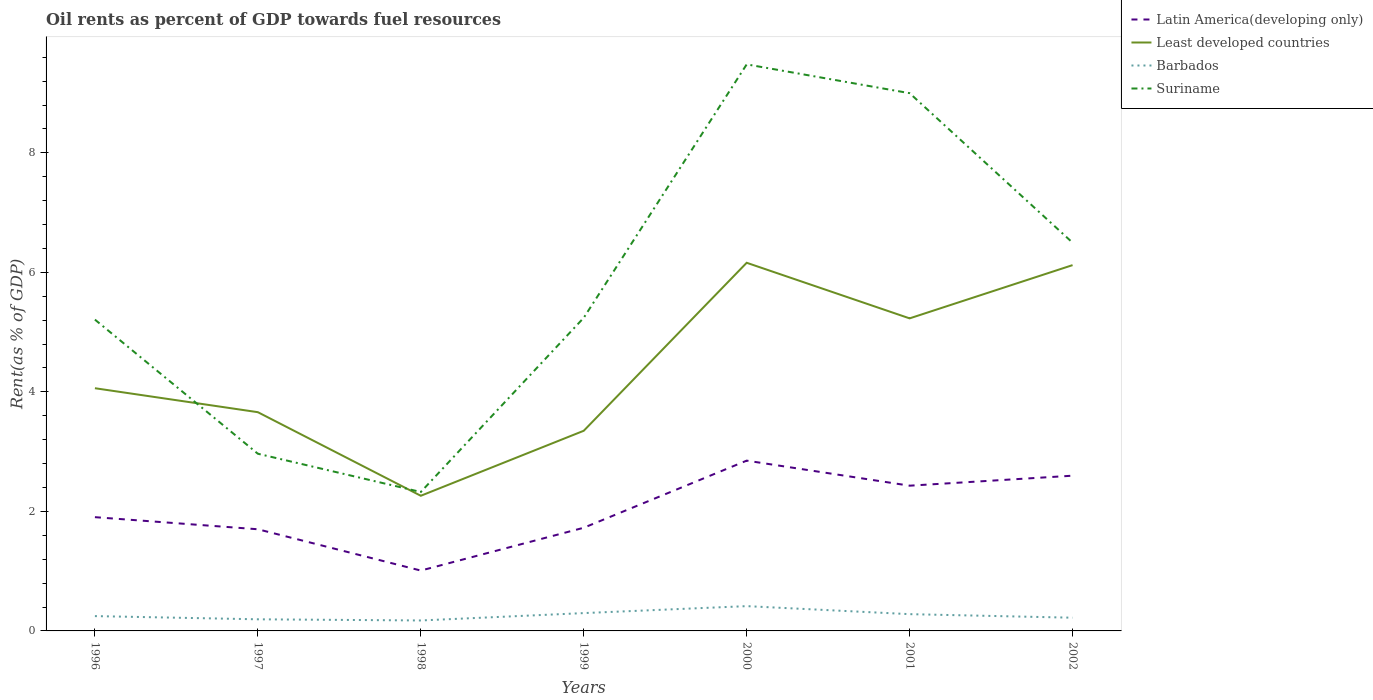Does the line corresponding to Latin America(developing only) intersect with the line corresponding to Least developed countries?
Offer a very short reply. No. Across all years, what is the maximum oil rent in Suriname?
Make the answer very short. 2.32. What is the total oil rent in Least developed countries in the graph?
Make the answer very short. -0.89. What is the difference between the highest and the second highest oil rent in Latin America(developing only)?
Offer a very short reply. 1.84. What is the difference between the highest and the lowest oil rent in Barbados?
Ensure brevity in your answer.  3. Is the oil rent in Least developed countries strictly greater than the oil rent in Latin America(developing only) over the years?
Give a very brief answer. No. How many years are there in the graph?
Offer a very short reply. 7. Does the graph contain any zero values?
Offer a terse response. No. Does the graph contain grids?
Give a very brief answer. No. How are the legend labels stacked?
Your response must be concise. Vertical. What is the title of the graph?
Your answer should be compact. Oil rents as percent of GDP towards fuel resources. Does "Bhutan" appear as one of the legend labels in the graph?
Offer a very short reply. No. What is the label or title of the X-axis?
Your answer should be compact. Years. What is the label or title of the Y-axis?
Offer a terse response. Rent(as % of GDP). What is the Rent(as % of GDP) in Latin America(developing only) in 1996?
Give a very brief answer. 1.9. What is the Rent(as % of GDP) of Least developed countries in 1996?
Ensure brevity in your answer.  4.06. What is the Rent(as % of GDP) of Barbados in 1996?
Ensure brevity in your answer.  0.25. What is the Rent(as % of GDP) in Suriname in 1996?
Make the answer very short. 5.21. What is the Rent(as % of GDP) of Latin America(developing only) in 1997?
Keep it short and to the point. 1.7. What is the Rent(as % of GDP) in Least developed countries in 1997?
Provide a short and direct response. 3.66. What is the Rent(as % of GDP) of Barbados in 1997?
Your answer should be very brief. 0.19. What is the Rent(as % of GDP) in Suriname in 1997?
Ensure brevity in your answer.  2.97. What is the Rent(as % of GDP) of Latin America(developing only) in 1998?
Your answer should be very brief. 1.01. What is the Rent(as % of GDP) in Least developed countries in 1998?
Keep it short and to the point. 2.26. What is the Rent(as % of GDP) of Barbados in 1998?
Make the answer very short. 0.18. What is the Rent(as % of GDP) in Suriname in 1998?
Keep it short and to the point. 2.32. What is the Rent(as % of GDP) in Latin America(developing only) in 1999?
Offer a very short reply. 1.73. What is the Rent(as % of GDP) in Least developed countries in 1999?
Give a very brief answer. 3.35. What is the Rent(as % of GDP) of Barbados in 1999?
Give a very brief answer. 0.3. What is the Rent(as % of GDP) in Suriname in 1999?
Your answer should be very brief. 5.24. What is the Rent(as % of GDP) of Latin America(developing only) in 2000?
Keep it short and to the point. 2.85. What is the Rent(as % of GDP) in Least developed countries in 2000?
Your answer should be very brief. 6.16. What is the Rent(as % of GDP) in Barbados in 2000?
Your response must be concise. 0.41. What is the Rent(as % of GDP) in Suriname in 2000?
Offer a terse response. 9.48. What is the Rent(as % of GDP) of Latin America(developing only) in 2001?
Keep it short and to the point. 2.43. What is the Rent(as % of GDP) of Least developed countries in 2001?
Your answer should be compact. 5.23. What is the Rent(as % of GDP) in Barbados in 2001?
Provide a short and direct response. 0.28. What is the Rent(as % of GDP) in Suriname in 2001?
Your answer should be compact. 9. What is the Rent(as % of GDP) in Latin America(developing only) in 2002?
Make the answer very short. 2.6. What is the Rent(as % of GDP) in Least developed countries in 2002?
Make the answer very short. 6.12. What is the Rent(as % of GDP) in Barbados in 2002?
Your answer should be compact. 0.22. What is the Rent(as % of GDP) in Suriname in 2002?
Offer a terse response. 6.5. Across all years, what is the maximum Rent(as % of GDP) in Latin America(developing only)?
Offer a very short reply. 2.85. Across all years, what is the maximum Rent(as % of GDP) in Least developed countries?
Your response must be concise. 6.16. Across all years, what is the maximum Rent(as % of GDP) in Barbados?
Your answer should be very brief. 0.41. Across all years, what is the maximum Rent(as % of GDP) of Suriname?
Your answer should be very brief. 9.48. Across all years, what is the minimum Rent(as % of GDP) in Latin America(developing only)?
Provide a succinct answer. 1.01. Across all years, what is the minimum Rent(as % of GDP) in Least developed countries?
Make the answer very short. 2.26. Across all years, what is the minimum Rent(as % of GDP) of Barbados?
Your answer should be compact. 0.18. Across all years, what is the minimum Rent(as % of GDP) in Suriname?
Your answer should be compact. 2.32. What is the total Rent(as % of GDP) of Latin America(developing only) in the graph?
Provide a short and direct response. 14.22. What is the total Rent(as % of GDP) in Least developed countries in the graph?
Offer a terse response. 30.85. What is the total Rent(as % of GDP) of Barbados in the graph?
Provide a succinct answer. 1.83. What is the total Rent(as % of GDP) in Suriname in the graph?
Ensure brevity in your answer.  40.72. What is the difference between the Rent(as % of GDP) of Latin America(developing only) in 1996 and that in 1997?
Offer a terse response. 0.2. What is the difference between the Rent(as % of GDP) of Least developed countries in 1996 and that in 1997?
Keep it short and to the point. 0.4. What is the difference between the Rent(as % of GDP) in Barbados in 1996 and that in 1997?
Provide a succinct answer. 0.05. What is the difference between the Rent(as % of GDP) in Suriname in 1996 and that in 1997?
Make the answer very short. 2.24. What is the difference between the Rent(as % of GDP) in Latin America(developing only) in 1996 and that in 1998?
Provide a short and direct response. 0.89. What is the difference between the Rent(as % of GDP) in Least developed countries in 1996 and that in 1998?
Ensure brevity in your answer.  1.8. What is the difference between the Rent(as % of GDP) in Barbados in 1996 and that in 1998?
Make the answer very short. 0.07. What is the difference between the Rent(as % of GDP) of Suriname in 1996 and that in 1998?
Give a very brief answer. 2.88. What is the difference between the Rent(as % of GDP) in Latin America(developing only) in 1996 and that in 1999?
Offer a very short reply. 0.18. What is the difference between the Rent(as % of GDP) in Least developed countries in 1996 and that in 1999?
Make the answer very short. 0.71. What is the difference between the Rent(as % of GDP) in Barbados in 1996 and that in 1999?
Your answer should be compact. -0.05. What is the difference between the Rent(as % of GDP) in Suriname in 1996 and that in 1999?
Keep it short and to the point. -0.03. What is the difference between the Rent(as % of GDP) of Latin America(developing only) in 1996 and that in 2000?
Provide a short and direct response. -0.95. What is the difference between the Rent(as % of GDP) of Least developed countries in 1996 and that in 2000?
Your response must be concise. -2.1. What is the difference between the Rent(as % of GDP) in Barbados in 1996 and that in 2000?
Your answer should be very brief. -0.17. What is the difference between the Rent(as % of GDP) in Suriname in 1996 and that in 2000?
Your answer should be compact. -4.27. What is the difference between the Rent(as % of GDP) of Latin America(developing only) in 1996 and that in 2001?
Offer a very short reply. -0.53. What is the difference between the Rent(as % of GDP) in Least developed countries in 1996 and that in 2001?
Make the answer very short. -1.17. What is the difference between the Rent(as % of GDP) in Barbados in 1996 and that in 2001?
Keep it short and to the point. -0.03. What is the difference between the Rent(as % of GDP) of Suriname in 1996 and that in 2001?
Ensure brevity in your answer.  -3.79. What is the difference between the Rent(as % of GDP) in Latin America(developing only) in 1996 and that in 2002?
Make the answer very short. -0.69. What is the difference between the Rent(as % of GDP) in Least developed countries in 1996 and that in 2002?
Your answer should be very brief. -2.06. What is the difference between the Rent(as % of GDP) of Barbados in 1996 and that in 2002?
Your answer should be very brief. 0.03. What is the difference between the Rent(as % of GDP) of Suriname in 1996 and that in 2002?
Your response must be concise. -1.29. What is the difference between the Rent(as % of GDP) of Latin America(developing only) in 1997 and that in 1998?
Ensure brevity in your answer.  0.69. What is the difference between the Rent(as % of GDP) in Least developed countries in 1997 and that in 1998?
Offer a terse response. 1.4. What is the difference between the Rent(as % of GDP) of Barbados in 1997 and that in 1998?
Your answer should be very brief. 0.02. What is the difference between the Rent(as % of GDP) of Suriname in 1997 and that in 1998?
Make the answer very short. 0.64. What is the difference between the Rent(as % of GDP) of Latin America(developing only) in 1997 and that in 1999?
Offer a very short reply. -0.03. What is the difference between the Rent(as % of GDP) of Least developed countries in 1997 and that in 1999?
Give a very brief answer. 0.31. What is the difference between the Rent(as % of GDP) of Barbados in 1997 and that in 1999?
Ensure brevity in your answer.  -0.1. What is the difference between the Rent(as % of GDP) in Suriname in 1997 and that in 1999?
Provide a short and direct response. -2.27. What is the difference between the Rent(as % of GDP) of Latin America(developing only) in 1997 and that in 2000?
Make the answer very short. -1.15. What is the difference between the Rent(as % of GDP) in Least developed countries in 1997 and that in 2000?
Your answer should be compact. -2.5. What is the difference between the Rent(as % of GDP) of Barbados in 1997 and that in 2000?
Ensure brevity in your answer.  -0.22. What is the difference between the Rent(as % of GDP) in Suriname in 1997 and that in 2000?
Provide a succinct answer. -6.52. What is the difference between the Rent(as % of GDP) in Latin America(developing only) in 1997 and that in 2001?
Offer a terse response. -0.73. What is the difference between the Rent(as % of GDP) in Least developed countries in 1997 and that in 2001?
Ensure brevity in your answer.  -1.57. What is the difference between the Rent(as % of GDP) in Barbados in 1997 and that in 2001?
Provide a short and direct response. -0.09. What is the difference between the Rent(as % of GDP) of Suriname in 1997 and that in 2001?
Your answer should be very brief. -6.03. What is the difference between the Rent(as % of GDP) in Latin America(developing only) in 1997 and that in 2002?
Your answer should be compact. -0.9. What is the difference between the Rent(as % of GDP) in Least developed countries in 1997 and that in 2002?
Provide a succinct answer. -2.46. What is the difference between the Rent(as % of GDP) of Barbados in 1997 and that in 2002?
Ensure brevity in your answer.  -0.03. What is the difference between the Rent(as % of GDP) of Suriname in 1997 and that in 2002?
Make the answer very short. -3.53. What is the difference between the Rent(as % of GDP) of Latin America(developing only) in 1998 and that in 1999?
Your response must be concise. -0.72. What is the difference between the Rent(as % of GDP) in Least developed countries in 1998 and that in 1999?
Offer a terse response. -1.09. What is the difference between the Rent(as % of GDP) in Barbados in 1998 and that in 1999?
Offer a terse response. -0.12. What is the difference between the Rent(as % of GDP) in Suriname in 1998 and that in 1999?
Give a very brief answer. -2.92. What is the difference between the Rent(as % of GDP) in Latin America(developing only) in 1998 and that in 2000?
Offer a terse response. -1.84. What is the difference between the Rent(as % of GDP) of Least developed countries in 1998 and that in 2000?
Provide a short and direct response. -3.9. What is the difference between the Rent(as % of GDP) in Barbados in 1998 and that in 2000?
Your response must be concise. -0.24. What is the difference between the Rent(as % of GDP) in Suriname in 1998 and that in 2000?
Make the answer very short. -7.16. What is the difference between the Rent(as % of GDP) of Latin America(developing only) in 1998 and that in 2001?
Offer a very short reply. -1.42. What is the difference between the Rent(as % of GDP) in Least developed countries in 1998 and that in 2001?
Your response must be concise. -2.97. What is the difference between the Rent(as % of GDP) in Barbados in 1998 and that in 2001?
Keep it short and to the point. -0.11. What is the difference between the Rent(as % of GDP) in Suriname in 1998 and that in 2001?
Offer a terse response. -6.67. What is the difference between the Rent(as % of GDP) in Latin America(developing only) in 1998 and that in 2002?
Give a very brief answer. -1.59. What is the difference between the Rent(as % of GDP) in Least developed countries in 1998 and that in 2002?
Your answer should be compact. -3.86. What is the difference between the Rent(as % of GDP) of Barbados in 1998 and that in 2002?
Give a very brief answer. -0.05. What is the difference between the Rent(as % of GDP) of Suriname in 1998 and that in 2002?
Your response must be concise. -4.17. What is the difference between the Rent(as % of GDP) of Latin America(developing only) in 1999 and that in 2000?
Ensure brevity in your answer.  -1.12. What is the difference between the Rent(as % of GDP) in Least developed countries in 1999 and that in 2000?
Offer a very short reply. -2.81. What is the difference between the Rent(as % of GDP) in Barbados in 1999 and that in 2000?
Your answer should be very brief. -0.12. What is the difference between the Rent(as % of GDP) in Suriname in 1999 and that in 2000?
Make the answer very short. -4.24. What is the difference between the Rent(as % of GDP) of Latin America(developing only) in 1999 and that in 2001?
Provide a short and direct response. -0.7. What is the difference between the Rent(as % of GDP) in Least developed countries in 1999 and that in 2001?
Give a very brief answer. -1.88. What is the difference between the Rent(as % of GDP) in Barbados in 1999 and that in 2001?
Your answer should be very brief. 0.02. What is the difference between the Rent(as % of GDP) in Suriname in 1999 and that in 2001?
Your answer should be very brief. -3.76. What is the difference between the Rent(as % of GDP) in Latin America(developing only) in 1999 and that in 2002?
Provide a short and direct response. -0.87. What is the difference between the Rent(as % of GDP) in Least developed countries in 1999 and that in 2002?
Ensure brevity in your answer.  -2.77. What is the difference between the Rent(as % of GDP) of Barbados in 1999 and that in 2002?
Offer a terse response. 0.08. What is the difference between the Rent(as % of GDP) in Suriname in 1999 and that in 2002?
Give a very brief answer. -1.26. What is the difference between the Rent(as % of GDP) in Latin America(developing only) in 2000 and that in 2001?
Provide a succinct answer. 0.42. What is the difference between the Rent(as % of GDP) of Least developed countries in 2000 and that in 2001?
Provide a short and direct response. 0.93. What is the difference between the Rent(as % of GDP) in Barbados in 2000 and that in 2001?
Give a very brief answer. 0.13. What is the difference between the Rent(as % of GDP) in Suriname in 2000 and that in 2001?
Give a very brief answer. 0.48. What is the difference between the Rent(as % of GDP) of Latin America(developing only) in 2000 and that in 2002?
Offer a terse response. 0.25. What is the difference between the Rent(as % of GDP) of Least developed countries in 2000 and that in 2002?
Your response must be concise. 0.04. What is the difference between the Rent(as % of GDP) in Barbados in 2000 and that in 2002?
Ensure brevity in your answer.  0.19. What is the difference between the Rent(as % of GDP) in Suriname in 2000 and that in 2002?
Offer a terse response. 2.98. What is the difference between the Rent(as % of GDP) in Latin America(developing only) in 2001 and that in 2002?
Your answer should be compact. -0.17. What is the difference between the Rent(as % of GDP) of Least developed countries in 2001 and that in 2002?
Ensure brevity in your answer.  -0.89. What is the difference between the Rent(as % of GDP) in Barbados in 2001 and that in 2002?
Offer a terse response. 0.06. What is the difference between the Rent(as % of GDP) of Suriname in 2001 and that in 2002?
Ensure brevity in your answer.  2.5. What is the difference between the Rent(as % of GDP) of Latin America(developing only) in 1996 and the Rent(as % of GDP) of Least developed countries in 1997?
Provide a succinct answer. -1.76. What is the difference between the Rent(as % of GDP) in Latin America(developing only) in 1996 and the Rent(as % of GDP) in Barbados in 1997?
Provide a short and direct response. 1.71. What is the difference between the Rent(as % of GDP) in Latin America(developing only) in 1996 and the Rent(as % of GDP) in Suriname in 1997?
Your response must be concise. -1.06. What is the difference between the Rent(as % of GDP) in Least developed countries in 1996 and the Rent(as % of GDP) in Barbados in 1997?
Keep it short and to the point. 3.87. What is the difference between the Rent(as % of GDP) of Least developed countries in 1996 and the Rent(as % of GDP) of Suriname in 1997?
Your answer should be very brief. 1.1. What is the difference between the Rent(as % of GDP) in Barbados in 1996 and the Rent(as % of GDP) in Suriname in 1997?
Ensure brevity in your answer.  -2.72. What is the difference between the Rent(as % of GDP) of Latin America(developing only) in 1996 and the Rent(as % of GDP) of Least developed countries in 1998?
Provide a succinct answer. -0.36. What is the difference between the Rent(as % of GDP) in Latin America(developing only) in 1996 and the Rent(as % of GDP) in Barbados in 1998?
Ensure brevity in your answer.  1.73. What is the difference between the Rent(as % of GDP) of Latin America(developing only) in 1996 and the Rent(as % of GDP) of Suriname in 1998?
Your answer should be very brief. -0.42. What is the difference between the Rent(as % of GDP) of Least developed countries in 1996 and the Rent(as % of GDP) of Barbados in 1998?
Your answer should be very brief. 3.89. What is the difference between the Rent(as % of GDP) of Least developed countries in 1996 and the Rent(as % of GDP) of Suriname in 1998?
Keep it short and to the point. 1.74. What is the difference between the Rent(as % of GDP) of Barbados in 1996 and the Rent(as % of GDP) of Suriname in 1998?
Your response must be concise. -2.08. What is the difference between the Rent(as % of GDP) of Latin America(developing only) in 1996 and the Rent(as % of GDP) of Least developed countries in 1999?
Keep it short and to the point. -1.45. What is the difference between the Rent(as % of GDP) in Latin America(developing only) in 1996 and the Rent(as % of GDP) in Barbados in 1999?
Keep it short and to the point. 1.61. What is the difference between the Rent(as % of GDP) of Latin America(developing only) in 1996 and the Rent(as % of GDP) of Suriname in 1999?
Make the answer very short. -3.34. What is the difference between the Rent(as % of GDP) in Least developed countries in 1996 and the Rent(as % of GDP) in Barbados in 1999?
Make the answer very short. 3.76. What is the difference between the Rent(as % of GDP) of Least developed countries in 1996 and the Rent(as % of GDP) of Suriname in 1999?
Offer a very short reply. -1.18. What is the difference between the Rent(as % of GDP) of Barbados in 1996 and the Rent(as % of GDP) of Suriname in 1999?
Make the answer very short. -4.99. What is the difference between the Rent(as % of GDP) in Latin America(developing only) in 1996 and the Rent(as % of GDP) in Least developed countries in 2000?
Provide a succinct answer. -4.26. What is the difference between the Rent(as % of GDP) in Latin America(developing only) in 1996 and the Rent(as % of GDP) in Barbados in 2000?
Offer a terse response. 1.49. What is the difference between the Rent(as % of GDP) in Latin America(developing only) in 1996 and the Rent(as % of GDP) in Suriname in 2000?
Ensure brevity in your answer.  -7.58. What is the difference between the Rent(as % of GDP) of Least developed countries in 1996 and the Rent(as % of GDP) of Barbados in 2000?
Keep it short and to the point. 3.65. What is the difference between the Rent(as % of GDP) of Least developed countries in 1996 and the Rent(as % of GDP) of Suriname in 2000?
Provide a short and direct response. -5.42. What is the difference between the Rent(as % of GDP) in Barbados in 1996 and the Rent(as % of GDP) in Suriname in 2000?
Make the answer very short. -9.23. What is the difference between the Rent(as % of GDP) in Latin America(developing only) in 1996 and the Rent(as % of GDP) in Least developed countries in 2001?
Provide a succinct answer. -3.33. What is the difference between the Rent(as % of GDP) of Latin America(developing only) in 1996 and the Rent(as % of GDP) of Barbados in 2001?
Your answer should be compact. 1.62. What is the difference between the Rent(as % of GDP) in Latin America(developing only) in 1996 and the Rent(as % of GDP) in Suriname in 2001?
Your response must be concise. -7.1. What is the difference between the Rent(as % of GDP) in Least developed countries in 1996 and the Rent(as % of GDP) in Barbados in 2001?
Provide a short and direct response. 3.78. What is the difference between the Rent(as % of GDP) of Least developed countries in 1996 and the Rent(as % of GDP) of Suriname in 2001?
Keep it short and to the point. -4.94. What is the difference between the Rent(as % of GDP) in Barbados in 1996 and the Rent(as % of GDP) in Suriname in 2001?
Provide a succinct answer. -8.75. What is the difference between the Rent(as % of GDP) in Latin America(developing only) in 1996 and the Rent(as % of GDP) in Least developed countries in 2002?
Make the answer very short. -4.22. What is the difference between the Rent(as % of GDP) of Latin America(developing only) in 1996 and the Rent(as % of GDP) of Barbados in 2002?
Offer a very short reply. 1.68. What is the difference between the Rent(as % of GDP) of Latin America(developing only) in 1996 and the Rent(as % of GDP) of Suriname in 2002?
Provide a succinct answer. -4.59. What is the difference between the Rent(as % of GDP) of Least developed countries in 1996 and the Rent(as % of GDP) of Barbados in 2002?
Keep it short and to the point. 3.84. What is the difference between the Rent(as % of GDP) of Least developed countries in 1996 and the Rent(as % of GDP) of Suriname in 2002?
Offer a terse response. -2.44. What is the difference between the Rent(as % of GDP) of Barbados in 1996 and the Rent(as % of GDP) of Suriname in 2002?
Your answer should be very brief. -6.25. What is the difference between the Rent(as % of GDP) of Latin America(developing only) in 1997 and the Rent(as % of GDP) of Least developed countries in 1998?
Provide a short and direct response. -0.56. What is the difference between the Rent(as % of GDP) in Latin America(developing only) in 1997 and the Rent(as % of GDP) in Barbados in 1998?
Provide a succinct answer. 1.53. What is the difference between the Rent(as % of GDP) of Latin America(developing only) in 1997 and the Rent(as % of GDP) of Suriname in 1998?
Offer a terse response. -0.62. What is the difference between the Rent(as % of GDP) in Least developed countries in 1997 and the Rent(as % of GDP) in Barbados in 1998?
Give a very brief answer. 3.49. What is the difference between the Rent(as % of GDP) of Least developed countries in 1997 and the Rent(as % of GDP) of Suriname in 1998?
Your response must be concise. 1.34. What is the difference between the Rent(as % of GDP) of Barbados in 1997 and the Rent(as % of GDP) of Suriname in 1998?
Your answer should be very brief. -2.13. What is the difference between the Rent(as % of GDP) of Latin America(developing only) in 1997 and the Rent(as % of GDP) of Least developed countries in 1999?
Keep it short and to the point. -1.65. What is the difference between the Rent(as % of GDP) of Latin America(developing only) in 1997 and the Rent(as % of GDP) of Barbados in 1999?
Ensure brevity in your answer.  1.4. What is the difference between the Rent(as % of GDP) of Latin America(developing only) in 1997 and the Rent(as % of GDP) of Suriname in 1999?
Provide a short and direct response. -3.54. What is the difference between the Rent(as % of GDP) of Least developed countries in 1997 and the Rent(as % of GDP) of Barbados in 1999?
Your answer should be compact. 3.36. What is the difference between the Rent(as % of GDP) of Least developed countries in 1997 and the Rent(as % of GDP) of Suriname in 1999?
Ensure brevity in your answer.  -1.58. What is the difference between the Rent(as % of GDP) of Barbados in 1997 and the Rent(as % of GDP) of Suriname in 1999?
Offer a very short reply. -5.05. What is the difference between the Rent(as % of GDP) of Latin America(developing only) in 1997 and the Rent(as % of GDP) of Least developed countries in 2000?
Make the answer very short. -4.46. What is the difference between the Rent(as % of GDP) of Latin America(developing only) in 1997 and the Rent(as % of GDP) of Barbados in 2000?
Give a very brief answer. 1.29. What is the difference between the Rent(as % of GDP) of Latin America(developing only) in 1997 and the Rent(as % of GDP) of Suriname in 2000?
Your answer should be very brief. -7.78. What is the difference between the Rent(as % of GDP) in Least developed countries in 1997 and the Rent(as % of GDP) in Barbados in 2000?
Offer a terse response. 3.25. What is the difference between the Rent(as % of GDP) of Least developed countries in 1997 and the Rent(as % of GDP) of Suriname in 2000?
Provide a short and direct response. -5.82. What is the difference between the Rent(as % of GDP) of Barbados in 1997 and the Rent(as % of GDP) of Suriname in 2000?
Ensure brevity in your answer.  -9.29. What is the difference between the Rent(as % of GDP) in Latin America(developing only) in 1997 and the Rent(as % of GDP) in Least developed countries in 2001?
Offer a very short reply. -3.53. What is the difference between the Rent(as % of GDP) in Latin America(developing only) in 1997 and the Rent(as % of GDP) in Barbados in 2001?
Keep it short and to the point. 1.42. What is the difference between the Rent(as % of GDP) in Latin America(developing only) in 1997 and the Rent(as % of GDP) in Suriname in 2001?
Provide a short and direct response. -7.3. What is the difference between the Rent(as % of GDP) in Least developed countries in 1997 and the Rent(as % of GDP) in Barbados in 2001?
Offer a terse response. 3.38. What is the difference between the Rent(as % of GDP) of Least developed countries in 1997 and the Rent(as % of GDP) of Suriname in 2001?
Your response must be concise. -5.34. What is the difference between the Rent(as % of GDP) of Barbados in 1997 and the Rent(as % of GDP) of Suriname in 2001?
Provide a succinct answer. -8.8. What is the difference between the Rent(as % of GDP) in Latin America(developing only) in 1997 and the Rent(as % of GDP) in Least developed countries in 2002?
Your response must be concise. -4.42. What is the difference between the Rent(as % of GDP) in Latin America(developing only) in 1997 and the Rent(as % of GDP) in Barbados in 2002?
Keep it short and to the point. 1.48. What is the difference between the Rent(as % of GDP) of Latin America(developing only) in 1997 and the Rent(as % of GDP) of Suriname in 2002?
Ensure brevity in your answer.  -4.8. What is the difference between the Rent(as % of GDP) of Least developed countries in 1997 and the Rent(as % of GDP) of Barbados in 2002?
Give a very brief answer. 3.44. What is the difference between the Rent(as % of GDP) of Least developed countries in 1997 and the Rent(as % of GDP) of Suriname in 2002?
Provide a succinct answer. -2.84. What is the difference between the Rent(as % of GDP) in Barbados in 1997 and the Rent(as % of GDP) in Suriname in 2002?
Ensure brevity in your answer.  -6.3. What is the difference between the Rent(as % of GDP) in Latin America(developing only) in 1998 and the Rent(as % of GDP) in Least developed countries in 1999?
Keep it short and to the point. -2.34. What is the difference between the Rent(as % of GDP) in Latin America(developing only) in 1998 and the Rent(as % of GDP) in Barbados in 1999?
Ensure brevity in your answer.  0.71. What is the difference between the Rent(as % of GDP) of Latin America(developing only) in 1998 and the Rent(as % of GDP) of Suriname in 1999?
Make the answer very short. -4.23. What is the difference between the Rent(as % of GDP) in Least developed countries in 1998 and the Rent(as % of GDP) in Barbados in 1999?
Give a very brief answer. 1.96. What is the difference between the Rent(as % of GDP) in Least developed countries in 1998 and the Rent(as % of GDP) in Suriname in 1999?
Offer a very short reply. -2.98. What is the difference between the Rent(as % of GDP) of Barbados in 1998 and the Rent(as % of GDP) of Suriname in 1999?
Provide a succinct answer. -5.07. What is the difference between the Rent(as % of GDP) in Latin America(developing only) in 1998 and the Rent(as % of GDP) in Least developed countries in 2000?
Ensure brevity in your answer.  -5.15. What is the difference between the Rent(as % of GDP) in Latin America(developing only) in 1998 and the Rent(as % of GDP) in Barbados in 2000?
Provide a succinct answer. 0.6. What is the difference between the Rent(as % of GDP) in Latin America(developing only) in 1998 and the Rent(as % of GDP) in Suriname in 2000?
Keep it short and to the point. -8.47. What is the difference between the Rent(as % of GDP) in Least developed countries in 1998 and the Rent(as % of GDP) in Barbados in 2000?
Make the answer very short. 1.85. What is the difference between the Rent(as % of GDP) in Least developed countries in 1998 and the Rent(as % of GDP) in Suriname in 2000?
Provide a short and direct response. -7.22. What is the difference between the Rent(as % of GDP) in Barbados in 1998 and the Rent(as % of GDP) in Suriname in 2000?
Provide a short and direct response. -9.31. What is the difference between the Rent(as % of GDP) in Latin America(developing only) in 1998 and the Rent(as % of GDP) in Least developed countries in 2001?
Your response must be concise. -4.22. What is the difference between the Rent(as % of GDP) of Latin America(developing only) in 1998 and the Rent(as % of GDP) of Barbados in 2001?
Make the answer very short. 0.73. What is the difference between the Rent(as % of GDP) of Latin America(developing only) in 1998 and the Rent(as % of GDP) of Suriname in 2001?
Provide a succinct answer. -7.99. What is the difference between the Rent(as % of GDP) in Least developed countries in 1998 and the Rent(as % of GDP) in Barbados in 2001?
Ensure brevity in your answer.  1.98. What is the difference between the Rent(as % of GDP) in Least developed countries in 1998 and the Rent(as % of GDP) in Suriname in 2001?
Give a very brief answer. -6.74. What is the difference between the Rent(as % of GDP) of Barbados in 1998 and the Rent(as % of GDP) of Suriname in 2001?
Offer a very short reply. -8.82. What is the difference between the Rent(as % of GDP) in Latin America(developing only) in 1998 and the Rent(as % of GDP) in Least developed countries in 2002?
Provide a succinct answer. -5.11. What is the difference between the Rent(as % of GDP) of Latin America(developing only) in 1998 and the Rent(as % of GDP) of Barbados in 2002?
Ensure brevity in your answer.  0.79. What is the difference between the Rent(as % of GDP) in Latin America(developing only) in 1998 and the Rent(as % of GDP) in Suriname in 2002?
Your response must be concise. -5.49. What is the difference between the Rent(as % of GDP) in Least developed countries in 1998 and the Rent(as % of GDP) in Barbados in 2002?
Provide a short and direct response. 2.04. What is the difference between the Rent(as % of GDP) in Least developed countries in 1998 and the Rent(as % of GDP) in Suriname in 2002?
Your response must be concise. -4.24. What is the difference between the Rent(as % of GDP) of Barbados in 1998 and the Rent(as % of GDP) of Suriname in 2002?
Make the answer very short. -6.32. What is the difference between the Rent(as % of GDP) in Latin America(developing only) in 1999 and the Rent(as % of GDP) in Least developed countries in 2000?
Your response must be concise. -4.43. What is the difference between the Rent(as % of GDP) of Latin America(developing only) in 1999 and the Rent(as % of GDP) of Barbados in 2000?
Offer a terse response. 1.31. What is the difference between the Rent(as % of GDP) in Latin America(developing only) in 1999 and the Rent(as % of GDP) in Suriname in 2000?
Make the answer very short. -7.75. What is the difference between the Rent(as % of GDP) in Least developed countries in 1999 and the Rent(as % of GDP) in Barbados in 2000?
Your response must be concise. 2.93. What is the difference between the Rent(as % of GDP) in Least developed countries in 1999 and the Rent(as % of GDP) in Suriname in 2000?
Offer a terse response. -6.13. What is the difference between the Rent(as % of GDP) of Barbados in 1999 and the Rent(as % of GDP) of Suriname in 2000?
Your response must be concise. -9.18. What is the difference between the Rent(as % of GDP) of Latin America(developing only) in 1999 and the Rent(as % of GDP) of Least developed countries in 2001?
Provide a short and direct response. -3.5. What is the difference between the Rent(as % of GDP) of Latin America(developing only) in 1999 and the Rent(as % of GDP) of Barbados in 2001?
Make the answer very short. 1.45. What is the difference between the Rent(as % of GDP) in Latin America(developing only) in 1999 and the Rent(as % of GDP) in Suriname in 2001?
Your response must be concise. -7.27. What is the difference between the Rent(as % of GDP) of Least developed countries in 1999 and the Rent(as % of GDP) of Barbados in 2001?
Ensure brevity in your answer.  3.07. What is the difference between the Rent(as % of GDP) of Least developed countries in 1999 and the Rent(as % of GDP) of Suriname in 2001?
Your answer should be compact. -5.65. What is the difference between the Rent(as % of GDP) in Barbados in 1999 and the Rent(as % of GDP) in Suriname in 2001?
Ensure brevity in your answer.  -8.7. What is the difference between the Rent(as % of GDP) in Latin America(developing only) in 1999 and the Rent(as % of GDP) in Least developed countries in 2002?
Offer a very short reply. -4.39. What is the difference between the Rent(as % of GDP) in Latin America(developing only) in 1999 and the Rent(as % of GDP) in Barbados in 2002?
Keep it short and to the point. 1.51. What is the difference between the Rent(as % of GDP) of Latin America(developing only) in 1999 and the Rent(as % of GDP) of Suriname in 2002?
Your response must be concise. -4.77. What is the difference between the Rent(as % of GDP) of Least developed countries in 1999 and the Rent(as % of GDP) of Barbados in 2002?
Offer a terse response. 3.13. What is the difference between the Rent(as % of GDP) of Least developed countries in 1999 and the Rent(as % of GDP) of Suriname in 2002?
Give a very brief answer. -3.15. What is the difference between the Rent(as % of GDP) of Barbados in 1999 and the Rent(as % of GDP) of Suriname in 2002?
Provide a short and direct response. -6.2. What is the difference between the Rent(as % of GDP) of Latin America(developing only) in 2000 and the Rent(as % of GDP) of Least developed countries in 2001?
Ensure brevity in your answer.  -2.38. What is the difference between the Rent(as % of GDP) of Latin America(developing only) in 2000 and the Rent(as % of GDP) of Barbados in 2001?
Your response must be concise. 2.57. What is the difference between the Rent(as % of GDP) of Latin America(developing only) in 2000 and the Rent(as % of GDP) of Suriname in 2001?
Give a very brief answer. -6.15. What is the difference between the Rent(as % of GDP) of Least developed countries in 2000 and the Rent(as % of GDP) of Barbados in 2001?
Your response must be concise. 5.88. What is the difference between the Rent(as % of GDP) in Least developed countries in 2000 and the Rent(as % of GDP) in Suriname in 2001?
Keep it short and to the point. -2.84. What is the difference between the Rent(as % of GDP) of Barbados in 2000 and the Rent(as % of GDP) of Suriname in 2001?
Provide a short and direct response. -8.58. What is the difference between the Rent(as % of GDP) in Latin America(developing only) in 2000 and the Rent(as % of GDP) in Least developed countries in 2002?
Ensure brevity in your answer.  -3.27. What is the difference between the Rent(as % of GDP) of Latin America(developing only) in 2000 and the Rent(as % of GDP) of Barbados in 2002?
Your answer should be compact. 2.63. What is the difference between the Rent(as % of GDP) in Latin America(developing only) in 2000 and the Rent(as % of GDP) in Suriname in 2002?
Provide a succinct answer. -3.65. What is the difference between the Rent(as % of GDP) of Least developed countries in 2000 and the Rent(as % of GDP) of Barbados in 2002?
Give a very brief answer. 5.94. What is the difference between the Rent(as % of GDP) in Least developed countries in 2000 and the Rent(as % of GDP) in Suriname in 2002?
Give a very brief answer. -0.34. What is the difference between the Rent(as % of GDP) in Barbados in 2000 and the Rent(as % of GDP) in Suriname in 2002?
Provide a short and direct response. -6.08. What is the difference between the Rent(as % of GDP) in Latin America(developing only) in 2001 and the Rent(as % of GDP) in Least developed countries in 2002?
Offer a terse response. -3.69. What is the difference between the Rent(as % of GDP) of Latin America(developing only) in 2001 and the Rent(as % of GDP) of Barbados in 2002?
Provide a short and direct response. 2.21. What is the difference between the Rent(as % of GDP) of Latin America(developing only) in 2001 and the Rent(as % of GDP) of Suriname in 2002?
Keep it short and to the point. -4.07. What is the difference between the Rent(as % of GDP) of Least developed countries in 2001 and the Rent(as % of GDP) of Barbados in 2002?
Keep it short and to the point. 5.01. What is the difference between the Rent(as % of GDP) of Least developed countries in 2001 and the Rent(as % of GDP) of Suriname in 2002?
Keep it short and to the point. -1.27. What is the difference between the Rent(as % of GDP) in Barbados in 2001 and the Rent(as % of GDP) in Suriname in 2002?
Offer a terse response. -6.22. What is the average Rent(as % of GDP) of Latin America(developing only) per year?
Your answer should be compact. 2.03. What is the average Rent(as % of GDP) in Least developed countries per year?
Your response must be concise. 4.41. What is the average Rent(as % of GDP) in Barbados per year?
Make the answer very short. 0.26. What is the average Rent(as % of GDP) in Suriname per year?
Keep it short and to the point. 5.82. In the year 1996, what is the difference between the Rent(as % of GDP) of Latin America(developing only) and Rent(as % of GDP) of Least developed countries?
Make the answer very short. -2.16. In the year 1996, what is the difference between the Rent(as % of GDP) of Latin America(developing only) and Rent(as % of GDP) of Barbados?
Your response must be concise. 1.66. In the year 1996, what is the difference between the Rent(as % of GDP) of Latin America(developing only) and Rent(as % of GDP) of Suriname?
Make the answer very short. -3.31. In the year 1996, what is the difference between the Rent(as % of GDP) in Least developed countries and Rent(as % of GDP) in Barbados?
Give a very brief answer. 3.81. In the year 1996, what is the difference between the Rent(as % of GDP) in Least developed countries and Rent(as % of GDP) in Suriname?
Offer a terse response. -1.15. In the year 1996, what is the difference between the Rent(as % of GDP) of Barbados and Rent(as % of GDP) of Suriname?
Ensure brevity in your answer.  -4.96. In the year 1997, what is the difference between the Rent(as % of GDP) of Latin America(developing only) and Rent(as % of GDP) of Least developed countries?
Provide a succinct answer. -1.96. In the year 1997, what is the difference between the Rent(as % of GDP) in Latin America(developing only) and Rent(as % of GDP) in Barbados?
Your answer should be very brief. 1.51. In the year 1997, what is the difference between the Rent(as % of GDP) in Latin America(developing only) and Rent(as % of GDP) in Suriname?
Offer a terse response. -1.26. In the year 1997, what is the difference between the Rent(as % of GDP) of Least developed countries and Rent(as % of GDP) of Barbados?
Your answer should be compact. 3.47. In the year 1997, what is the difference between the Rent(as % of GDP) in Least developed countries and Rent(as % of GDP) in Suriname?
Your answer should be compact. 0.7. In the year 1997, what is the difference between the Rent(as % of GDP) of Barbados and Rent(as % of GDP) of Suriname?
Give a very brief answer. -2.77. In the year 1998, what is the difference between the Rent(as % of GDP) of Latin America(developing only) and Rent(as % of GDP) of Least developed countries?
Your answer should be compact. -1.25. In the year 1998, what is the difference between the Rent(as % of GDP) of Latin America(developing only) and Rent(as % of GDP) of Barbados?
Your answer should be compact. 0.84. In the year 1998, what is the difference between the Rent(as % of GDP) of Latin America(developing only) and Rent(as % of GDP) of Suriname?
Offer a very short reply. -1.31. In the year 1998, what is the difference between the Rent(as % of GDP) of Least developed countries and Rent(as % of GDP) of Barbados?
Ensure brevity in your answer.  2.09. In the year 1998, what is the difference between the Rent(as % of GDP) in Least developed countries and Rent(as % of GDP) in Suriname?
Offer a very short reply. -0.06. In the year 1998, what is the difference between the Rent(as % of GDP) in Barbados and Rent(as % of GDP) in Suriname?
Keep it short and to the point. -2.15. In the year 1999, what is the difference between the Rent(as % of GDP) of Latin America(developing only) and Rent(as % of GDP) of Least developed countries?
Your answer should be compact. -1.62. In the year 1999, what is the difference between the Rent(as % of GDP) of Latin America(developing only) and Rent(as % of GDP) of Barbados?
Your answer should be compact. 1.43. In the year 1999, what is the difference between the Rent(as % of GDP) in Latin America(developing only) and Rent(as % of GDP) in Suriname?
Give a very brief answer. -3.51. In the year 1999, what is the difference between the Rent(as % of GDP) of Least developed countries and Rent(as % of GDP) of Barbados?
Provide a succinct answer. 3.05. In the year 1999, what is the difference between the Rent(as % of GDP) of Least developed countries and Rent(as % of GDP) of Suriname?
Your answer should be very brief. -1.89. In the year 1999, what is the difference between the Rent(as % of GDP) in Barbados and Rent(as % of GDP) in Suriname?
Your answer should be very brief. -4.94. In the year 2000, what is the difference between the Rent(as % of GDP) in Latin America(developing only) and Rent(as % of GDP) in Least developed countries?
Offer a terse response. -3.31. In the year 2000, what is the difference between the Rent(as % of GDP) of Latin America(developing only) and Rent(as % of GDP) of Barbados?
Your answer should be very brief. 2.43. In the year 2000, what is the difference between the Rent(as % of GDP) in Latin America(developing only) and Rent(as % of GDP) in Suriname?
Provide a succinct answer. -6.63. In the year 2000, what is the difference between the Rent(as % of GDP) in Least developed countries and Rent(as % of GDP) in Barbados?
Provide a short and direct response. 5.75. In the year 2000, what is the difference between the Rent(as % of GDP) in Least developed countries and Rent(as % of GDP) in Suriname?
Your answer should be very brief. -3.32. In the year 2000, what is the difference between the Rent(as % of GDP) in Barbados and Rent(as % of GDP) in Suriname?
Provide a succinct answer. -9.07. In the year 2001, what is the difference between the Rent(as % of GDP) in Latin America(developing only) and Rent(as % of GDP) in Barbados?
Your answer should be very brief. 2.15. In the year 2001, what is the difference between the Rent(as % of GDP) of Latin America(developing only) and Rent(as % of GDP) of Suriname?
Keep it short and to the point. -6.57. In the year 2001, what is the difference between the Rent(as % of GDP) of Least developed countries and Rent(as % of GDP) of Barbados?
Provide a short and direct response. 4.95. In the year 2001, what is the difference between the Rent(as % of GDP) in Least developed countries and Rent(as % of GDP) in Suriname?
Your answer should be compact. -3.77. In the year 2001, what is the difference between the Rent(as % of GDP) in Barbados and Rent(as % of GDP) in Suriname?
Your answer should be compact. -8.72. In the year 2002, what is the difference between the Rent(as % of GDP) in Latin America(developing only) and Rent(as % of GDP) in Least developed countries?
Offer a terse response. -3.52. In the year 2002, what is the difference between the Rent(as % of GDP) of Latin America(developing only) and Rent(as % of GDP) of Barbados?
Your answer should be compact. 2.38. In the year 2002, what is the difference between the Rent(as % of GDP) of Latin America(developing only) and Rent(as % of GDP) of Suriname?
Provide a short and direct response. -3.9. In the year 2002, what is the difference between the Rent(as % of GDP) of Least developed countries and Rent(as % of GDP) of Barbados?
Keep it short and to the point. 5.9. In the year 2002, what is the difference between the Rent(as % of GDP) of Least developed countries and Rent(as % of GDP) of Suriname?
Make the answer very short. -0.38. In the year 2002, what is the difference between the Rent(as % of GDP) of Barbados and Rent(as % of GDP) of Suriname?
Ensure brevity in your answer.  -6.28. What is the ratio of the Rent(as % of GDP) of Latin America(developing only) in 1996 to that in 1997?
Your response must be concise. 1.12. What is the ratio of the Rent(as % of GDP) of Least developed countries in 1996 to that in 1997?
Ensure brevity in your answer.  1.11. What is the ratio of the Rent(as % of GDP) in Barbados in 1996 to that in 1997?
Provide a succinct answer. 1.28. What is the ratio of the Rent(as % of GDP) in Suriname in 1996 to that in 1997?
Your answer should be very brief. 1.76. What is the ratio of the Rent(as % of GDP) in Latin America(developing only) in 1996 to that in 1998?
Provide a short and direct response. 1.88. What is the ratio of the Rent(as % of GDP) of Least developed countries in 1996 to that in 1998?
Keep it short and to the point. 1.8. What is the ratio of the Rent(as % of GDP) of Barbados in 1996 to that in 1998?
Your answer should be compact. 1.42. What is the ratio of the Rent(as % of GDP) in Suriname in 1996 to that in 1998?
Make the answer very short. 2.24. What is the ratio of the Rent(as % of GDP) of Latin America(developing only) in 1996 to that in 1999?
Offer a terse response. 1.1. What is the ratio of the Rent(as % of GDP) of Least developed countries in 1996 to that in 1999?
Keep it short and to the point. 1.21. What is the ratio of the Rent(as % of GDP) of Barbados in 1996 to that in 1999?
Offer a terse response. 0.83. What is the ratio of the Rent(as % of GDP) of Latin America(developing only) in 1996 to that in 2000?
Ensure brevity in your answer.  0.67. What is the ratio of the Rent(as % of GDP) of Least developed countries in 1996 to that in 2000?
Make the answer very short. 0.66. What is the ratio of the Rent(as % of GDP) in Barbados in 1996 to that in 2000?
Keep it short and to the point. 0.6. What is the ratio of the Rent(as % of GDP) in Suriname in 1996 to that in 2000?
Your answer should be compact. 0.55. What is the ratio of the Rent(as % of GDP) in Latin America(developing only) in 1996 to that in 2001?
Your answer should be very brief. 0.78. What is the ratio of the Rent(as % of GDP) in Least developed countries in 1996 to that in 2001?
Provide a short and direct response. 0.78. What is the ratio of the Rent(as % of GDP) of Barbados in 1996 to that in 2001?
Ensure brevity in your answer.  0.88. What is the ratio of the Rent(as % of GDP) in Suriname in 1996 to that in 2001?
Provide a succinct answer. 0.58. What is the ratio of the Rent(as % of GDP) in Latin America(developing only) in 1996 to that in 2002?
Keep it short and to the point. 0.73. What is the ratio of the Rent(as % of GDP) in Least developed countries in 1996 to that in 2002?
Offer a very short reply. 0.66. What is the ratio of the Rent(as % of GDP) of Barbados in 1996 to that in 2002?
Make the answer very short. 1.12. What is the ratio of the Rent(as % of GDP) of Suriname in 1996 to that in 2002?
Give a very brief answer. 0.8. What is the ratio of the Rent(as % of GDP) in Latin America(developing only) in 1997 to that in 1998?
Provide a short and direct response. 1.68. What is the ratio of the Rent(as % of GDP) in Least developed countries in 1997 to that in 1998?
Give a very brief answer. 1.62. What is the ratio of the Rent(as % of GDP) in Barbados in 1997 to that in 1998?
Ensure brevity in your answer.  1.11. What is the ratio of the Rent(as % of GDP) of Suriname in 1997 to that in 1998?
Your answer should be very brief. 1.28. What is the ratio of the Rent(as % of GDP) in Latin America(developing only) in 1997 to that in 1999?
Provide a succinct answer. 0.99. What is the ratio of the Rent(as % of GDP) of Least developed countries in 1997 to that in 1999?
Ensure brevity in your answer.  1.09. What is the ratio of the Rent(as % of GDP) in Barbados in 1997 to that in 1999?
Your answer should be compact. 0.65. What is the ratio of the Rent(as % of GDP) of Suriname in 1997 to that in 1999?
Provide a short and direct response. 0.57. What is the ratio of the Rent(as % of GDP) of Latin America(developing only) in 1997 to that in 2000?
Give a very brief answer. 0.6. What is the ratio of the Rent(as % of GDP) of Least developed countries in 1997 to that in 2000?
Your answer should be compact. 0.59. What is the ratio of the Rent(as % of GDP) in Barbados in 1997 to that in 2000?
Keep it short and to the point. 0.47. What is the ratio of the Rent(as % of GDP) in Suriname in 1997 to that in 2000?
Make the answer very short. 0.31. What is the ratio of the Rent(as % of GDP) in Latin America(developing only) in 1997 to that in 2001?
Ensure brevity in your answer.  0.7. What is the ratio of the Rent(as % of GDP) of Least developed countries in 1997 to that in 2001?
Your response must be concise. 0.7. What is the ratio of the Rent(as % of GDP) of Barbados in 1997 to that in 2001?
Offer a very short reply. 0.69. What is the ratio of the Rent(as % of GDP) of Suriname in 1997 to that in 2001?
Your answer should be very brief. 0.33. What is the ratio of the Rent(as % of GDP) of Latin America(developing only) in 1997 to that in 2002?
Offer a terse response. 0.65. What is the ratio of the Rent(as % of GDP) in Least developed countries in 1997 to that in 2002?
Provide a short and direct response. 0.6. What is the ratio of the Rent(as % of GDP) of Barbados in 1997 to that in 2002?
Your response must be concise. 0.88. What is the ratio of the Rent(as % of GDP) in Suriname in 1997 to that in 2002?
Provide a short and direct response. 0.46. What is the ratio of the Rent(as % of GDP) of Latin America(developing only) in 1998 to that in 1999?
Make the answer very short. 0.59. What is the ratio of the Rent(as % of GDP) of Least developed countries in 1998 to that in 1999?
Provide a short and direct response. 0.68. What is the ratio of the Rent(as % of GDP) in Barbados in 1998 to that in 1999?
Keep it short and to the point. 0.59. What is the ratio of the Rent(as % of GDP) in Suriname in 1998 to that in 1999?
Provide a succinct answer. 0.44. What is the ratio of the Rent(as % of GDP) of Latin America(developing only) in 1998 to that in 2000?
Provide a short and direct response. 0.35. What is the ratio of the Rent(as % of GDP) in Least developed countries in 1998 to that in 2000?
Your answer should be compact. 0.37. What is the ratio of the Rent(as % of GDP) of Barbados in 1998 to that in 2000?
Provide a short and direct response. 0.42. What is the ratio of the Rent(as % of GDP) of Suriname in 1998 to that in 2000?
Offer a terse response. 0.25. What is the ratio of the Rent(as % of GDP) of Latin America(developing only) in 1998 to that in 2001?
Provide a short and direct response. 0.42. What is the ratio of the Rent(as % of GDP) in Least developed countries in 1998 to that in 2001?
Offer a terse response. 0.43. What is the ratio of the Rent(as % of GDP) in Barbados in 1998 to that in 2001?
Offer a terse response. 0.62. What is the ratio of the Rent(as % of GDP) of Suriname in 1998 to that in 2001?
Ensure brevity in your answer.  0.26. What is the ratio of the Rent(as % of GDP) in Latin America(developing only) in 1998 to that in 2002?
Offer a very short reply. 0.39. What is the ratio of the Rent(as % of GDP) of Least developed countries in 1998 to that in 2002?
Your answer should be very brief. 0.37. What is the ratio of the Rent(as % of GDP) in Barbados in 1998 to that in 2002?
Your answer should be compact. 0.79. What is the ratio of the Rent(as % of GDP) of Suriname in 1998 to that in 2002?
Provide a short and direct response. 0.36. What is the ratio of the Rent(as % of GDP) of Latin America(developing only) in 1999 to that in 2000?
Ensure brevity in your answer.  0.61. What is the ratio of the Rent(as % of GDP) in Least developed countries in 1999 to that in 2000?
Provide a short and direct response. 0.54. What is the ratio of the Rent(as % of GDP) in Barbados in 1999 to that in 2000?
Give a very brief answer. 0.72. What is the ratio of the Rent(as % of GDP) in Suriname in 1999 to that in 2000?
Offer a very short reply. 0.55. What is the ratio of the Rent(as % of GDP) in Latin America(developing only) in 1999 to that in 2001?
Make the answer very short. 0.71. What is the ratio of the Rent(as % of GDP) in Least developed countries in 1999 to that in 2001?
Provide a succinct answer. 0.64. What is the ratio of the Rent(as % of GDP) of Barbados in 1999 to that in 2001?
Keep it short and to the point. 1.06. What is the ratio of the Rent(as % of GDP) in Suriname in 1999 to that in 2001?
Your answer should be compact. 0.58. What is the ratio of the Rent(as % of GDP) in Latin America(developing only) in 1999 to that in 2002?
Offer a terse response. 0.66. What is the ratio of the Rent(as % of GDP) in Least developed countries in 1999 to that in 2002?
Ensure brevity in your answer.  0.55. What is the ratio of the Rent(as % of GDP) in Barbados in 1999 to that in 2002?
Your answer should be compact. 1.35. What is the ratio of the Rent(as % of GDP) of Suriname in 1999 to that in 2002?
Your answer should be compact. 0.81. What is the ratio of the Rent(as % of GDP) in Latin America(developing only) in 2000 to that in 2001?
Your response must be concise. 1.17. What is the ratio of the Rent(as % of GDP) of Least developed countries in 2000 to that in 2001?
Offer a terse response. 1.18. What is the ratio of the Rent(as % of GDP) of Barbados in 2000 to that in 2001?
Offer a terse response. 1.48. What is the ratio of the Rent(as % of GDP) in Suriname in 2000 to that in 2001?
Your answer should be compact. 1.05. What is the ratio of the Rent(as % of GDP) in Latin America(developing only) in 2000 to that in 2002?
Offer a terse response. 1.1. What is the ratio of the Rent(as % of GDP) in Least developed countries in 2000 to that in 2002?
Your response must be concise. 1.01. What is the ratio of the Rent(as % of GDP) of Barbados in 2000 to that in 2002?
Your answer should be compact. 1.88. What is the ratio of the Rent(as % of GDP) of Suriname in 2000 to that in 2002?
Provide a succinct answer. 1.46. What is the ratio of the Rent(as % of GDP) of Latin America(developing only) in 2001 to that in 2002?
Your answer should be compact. 0.94. What is the ratio of the Rent(as % of GDP) of Least developed countries in 2001 to that in 2002?
Provide a short and direct response. 0.85. What is the ratio of the Rent(as % of GDP) of Barbados in 2001 to that in 2002?
Provide a short and direct response. 1.27. What is the ratio of the Rent(as % of GDP) of Suriname in 2001 to that in 2002?
Keep it short and to the point. 1.39. What is the difference between the highest and the second highest Rent(as % of GDP) of Latin America(developing only)?
Make the answer very short. 0.25. What is the difference between the highest and the second highest Rent(as % of GDP) of Least developed countries?
Provide a short and direct response. 0.04. What is the difference between the highest and the second highest Rent(as % of GDP) of Barbados?
Your answer should be compact. 0.12. What is the difference between the highest and the second highest Rent(as % of GDP) in Suriname?
Your answer should be very brief. 0.48. What is the difference between the highest and the lowest Rent(as % of GDP) of Latin America(developing only)?
Provide a succinct answer. 1.84. What is the difference between the highest and the lowest Rent(as % of GDP) in Least developed countries?
Keep it short and to the point. 3.9. What is the difference between the highest and the lowest Rent(as % of GDP) of Barbados?
Ensure brevity in your answer.  0.24. What is the difference between the highest and the lowest Rent(as % of GDP) of Suriname?
Ensure brevity in your answer.  7.16. 